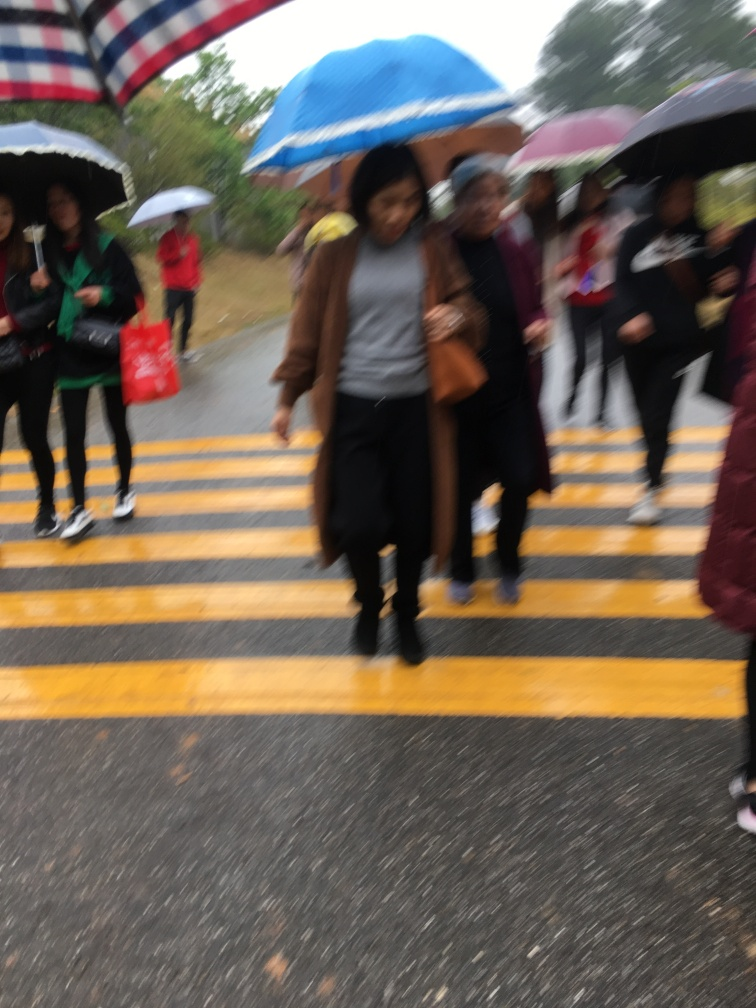What weather does this picture suggest? The people are using umbrellas, which typically suggests rainy or drizzly weather. 